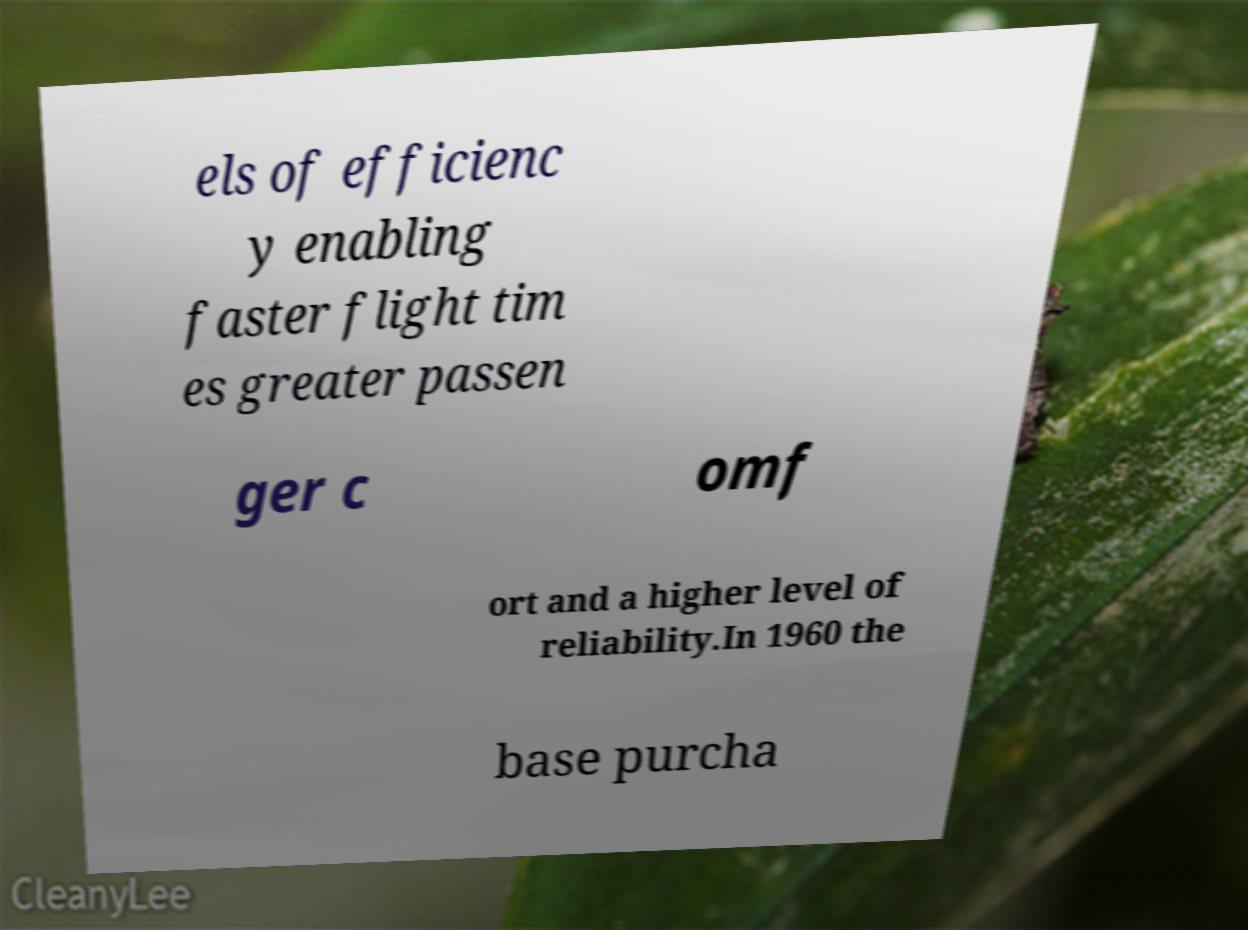For documentation purposes, I need the text within this image transcribed. Could you provide that? els of efficienc y enabling faster flight tim es greater passen ger c omf ort and a higher level of reliability.In 1960 the base purcha 